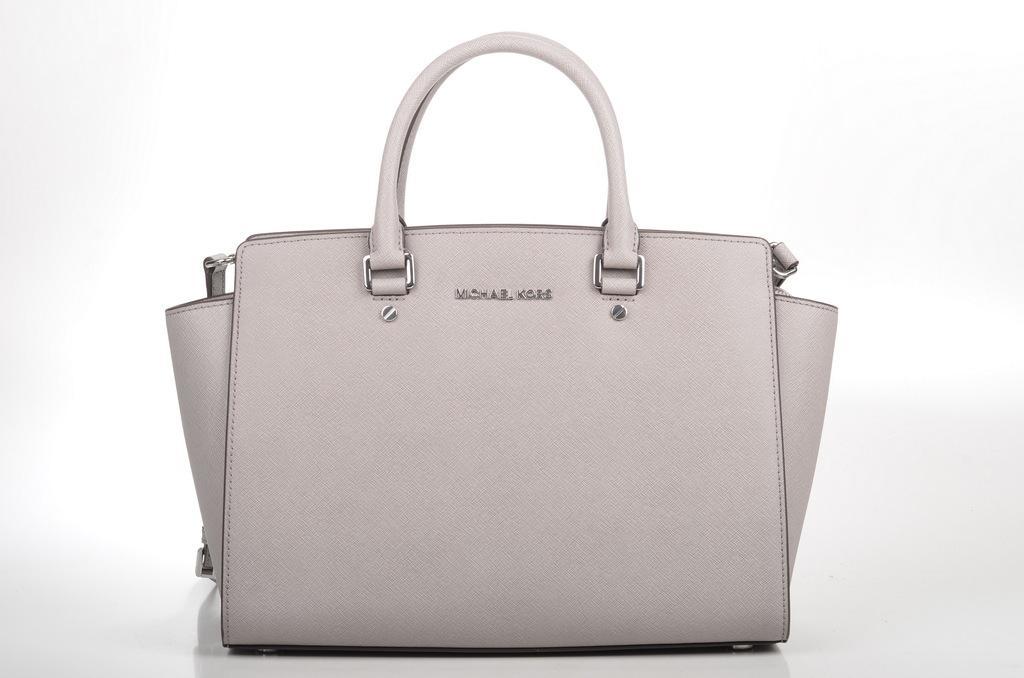Can you describe this image briefly? In this image I can see a handbag. 